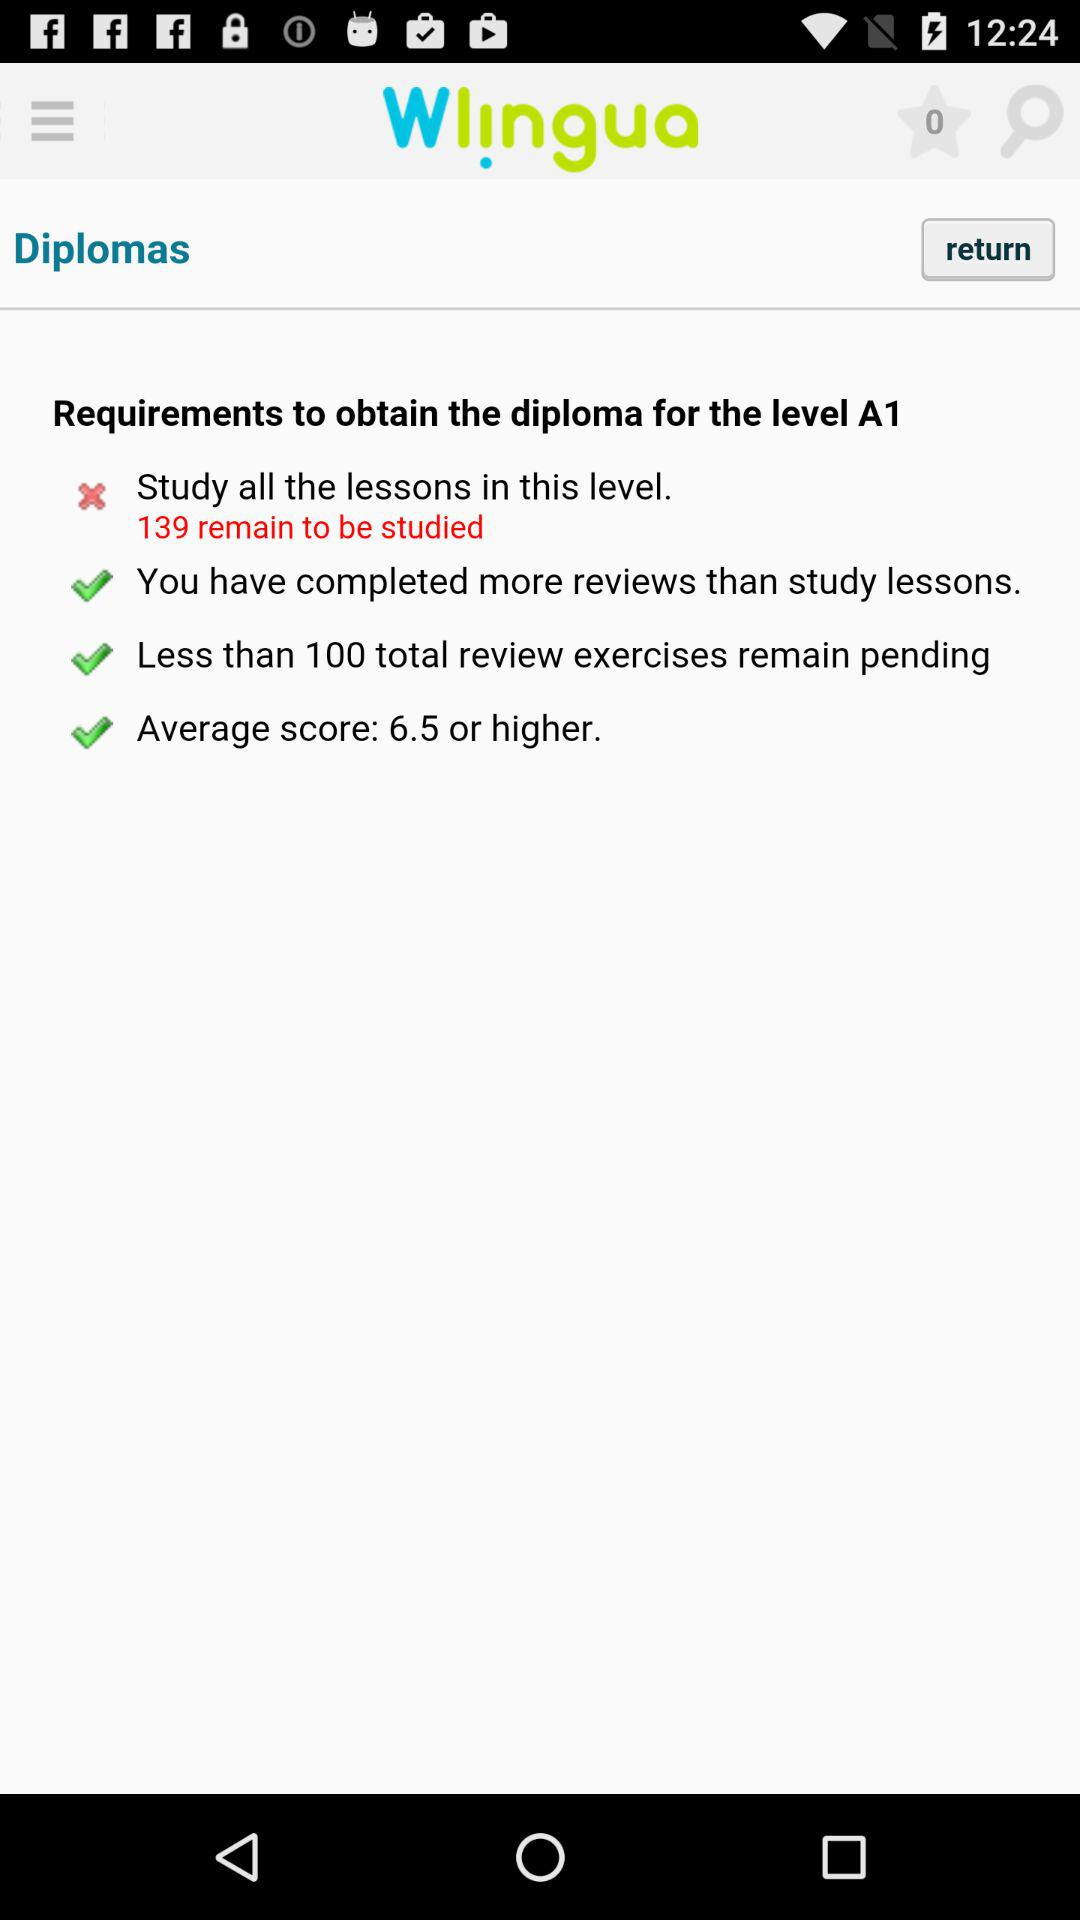What is the app name? The app name is "Wlᴉngua". 